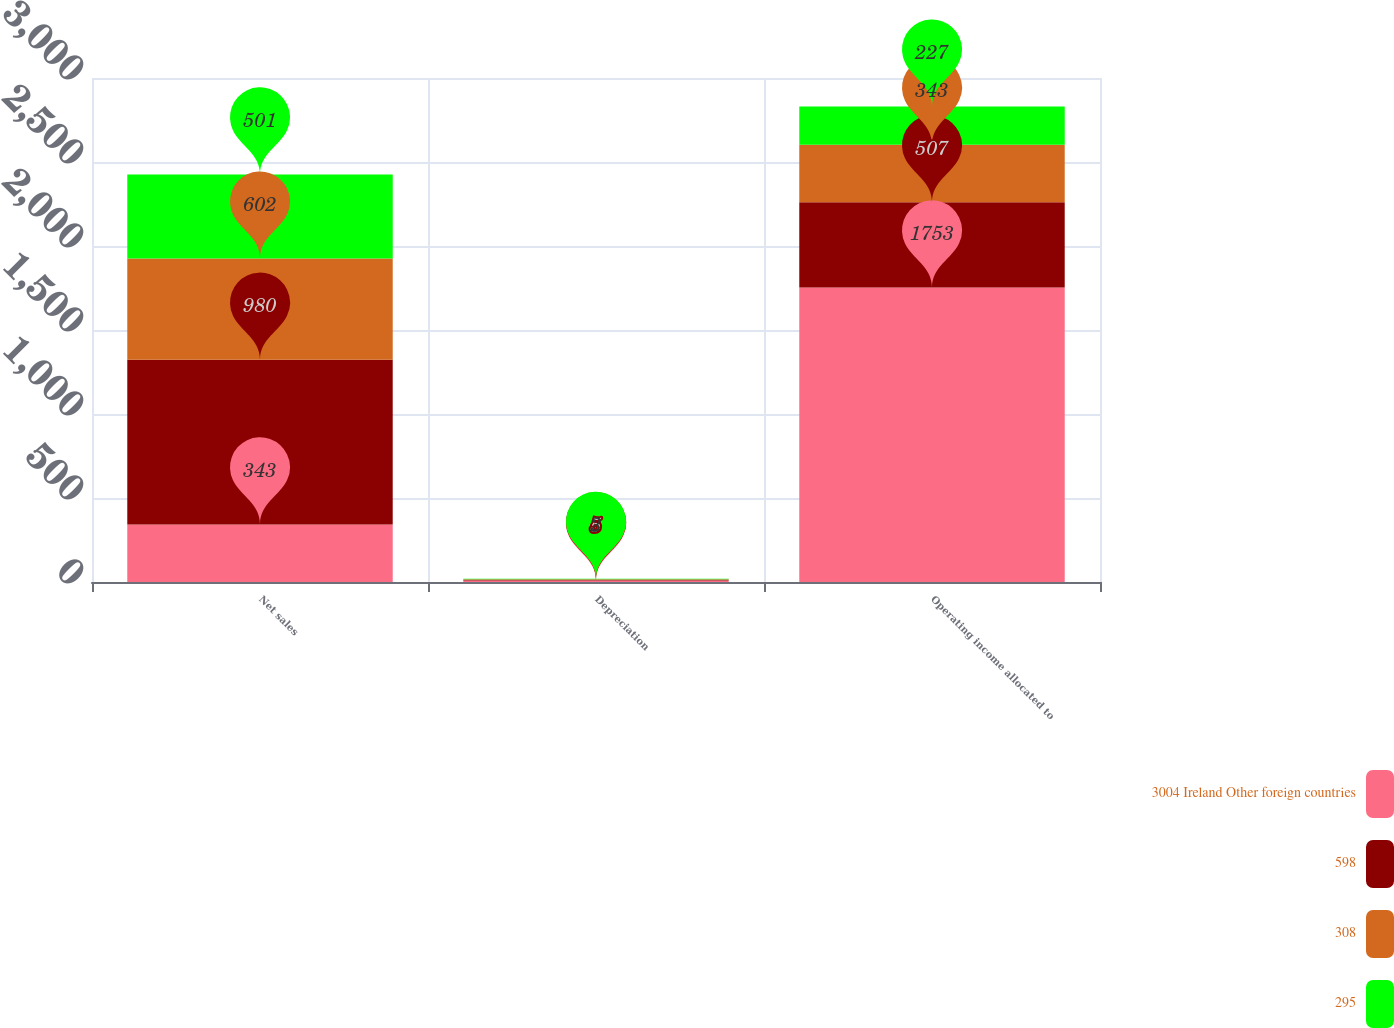Convert chart to OTSL. <chart><loc_0><loc_0><loc_500><loc_500><stacked_bar_chart><ecel><fcel>Net sales<fcel>Depreciation<fcel>Operating income allocated to<nl><fcel>3004 Ireland Other foreign countries<fcel>343<fcel>9<fcel>1753<nl><fcel>598<fcel>980<fcel>5<fcel>507<nl><fcel>308<fcel>602<fcel>3<fcel>343<nl><fcel>295<fcel>501<fcel>2<fcel>227<nl></chart> 